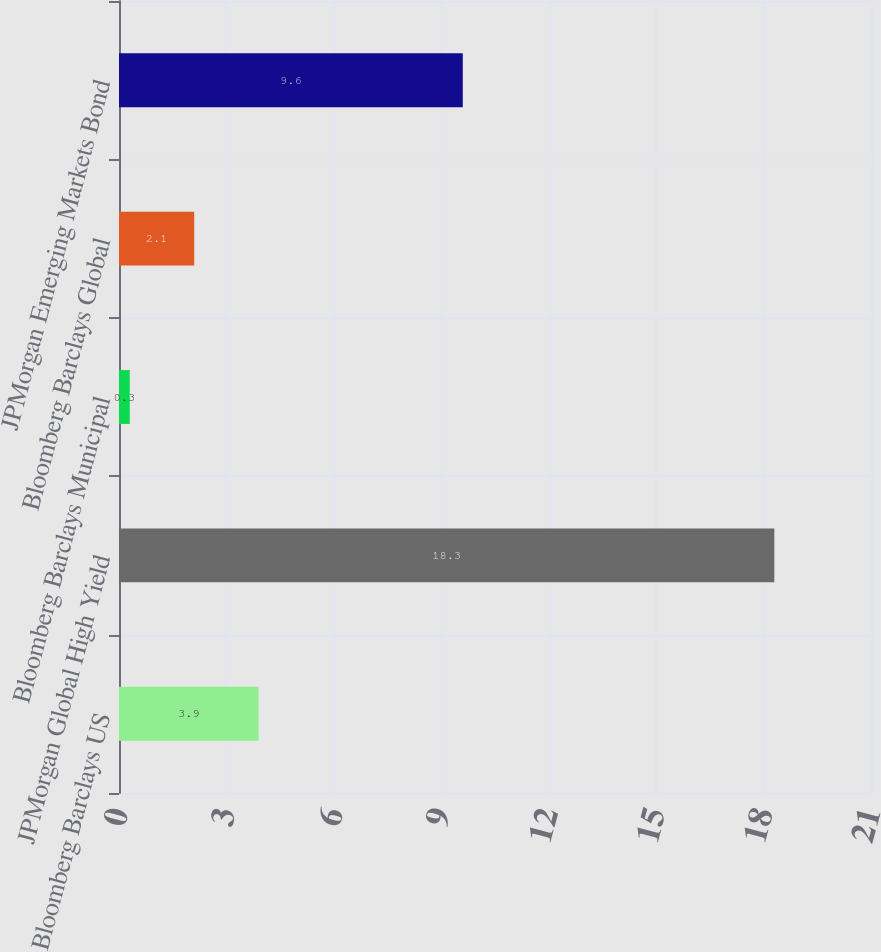<chart> <loc_0><loc_0><loc_500><loc_500><bar_chart><fcel>Bloomberg Barclays US<fcel>JPMorgan Global High Yield<fcel>Bloomberg Barclays Municipal<fcel>Bloomberg Barclays Global<fcel>JPMorgan Emerging Markets Bond<nl><fcel>3.9<fcel>18.3<fcel>0.3<fcel>2.1<fcel>9.6<nl></chart> 